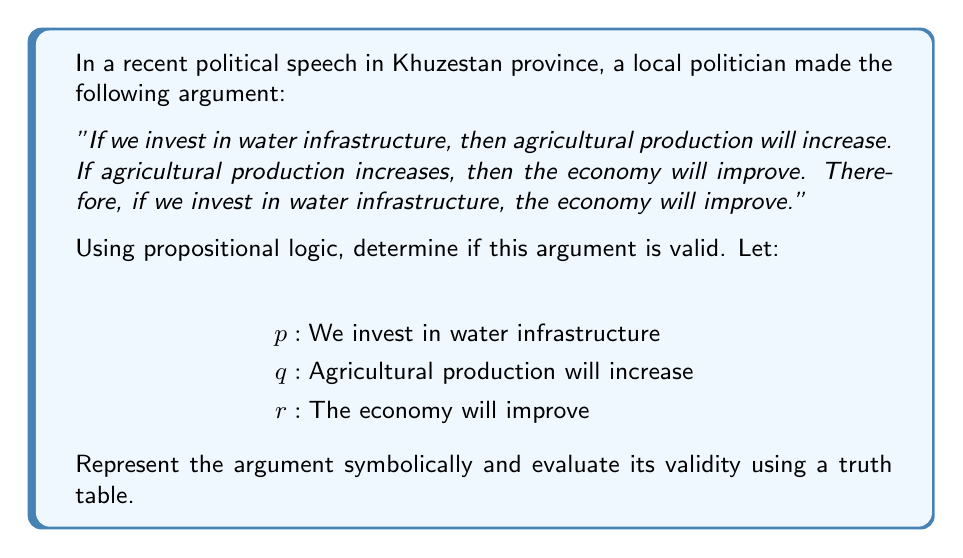Show me your answer to this math problem. To evaluate the validity of this argument using propositional logic, we need to follow these steps:

1. Represent the argument symbolically:
   Premise 1: $p \rightarrow q$
   Premise 2: $q \rightarrow r$
   Conclusion: $p \rightarrow r$

2. The argument form is:
   $$(p \rightarrow q) \land (q \rightarrow r) \therefore (p \rightarrow r)$$

   This is known as the hypothetical syllogism.

3. To prove validity, we need to show that whenever all premises are true, the conclusion must also be true. We can do this using a truth table.

4. Construct the truth table:

   $$\begin{array}{cccccc}
   p & q & r & p \rightarrow q & q \rightarrow r & p \rightarrow r \\
   \hline
   T & T & T & T & T & T \\
   T & T & F & T & F & F \\
   T & F & T & F & T & T \\
   T & F & F & F & T & F \\
   F & T & T & T & T & T \\
   F & T & F & T & F & T \\
   F & F & T & T & T & T \\
   F & F & F & T & T & T \\
   \end{array}$$

5. Analyze the truth table:
   - The premises $(p \rightarrow q)$ and $(q \rightarrow r)$ are both true in rows 1, 5, 7, and 8.
   - In all of these rows, the conclusion $(p \rightarrow r)$ is also true.
   - This means that whenever both premises are true, the conclusion is also true.

6. Therefore, the argument is valid.

This logical analysis shows that the politician's argument structure is valid, regardless of the actual truth of the statements about water infrastructure, agricultural production, and economic improvement in Khuzestan province.
Answer: The argument is valid. The truth table shows that whenever both premises $(p \rightarrow q)$ and $(q \rightarrow r)$ are true, the conclusion $(p \rightarrow r)$ is also true, proving the validity of the hypothetical syllogism. 